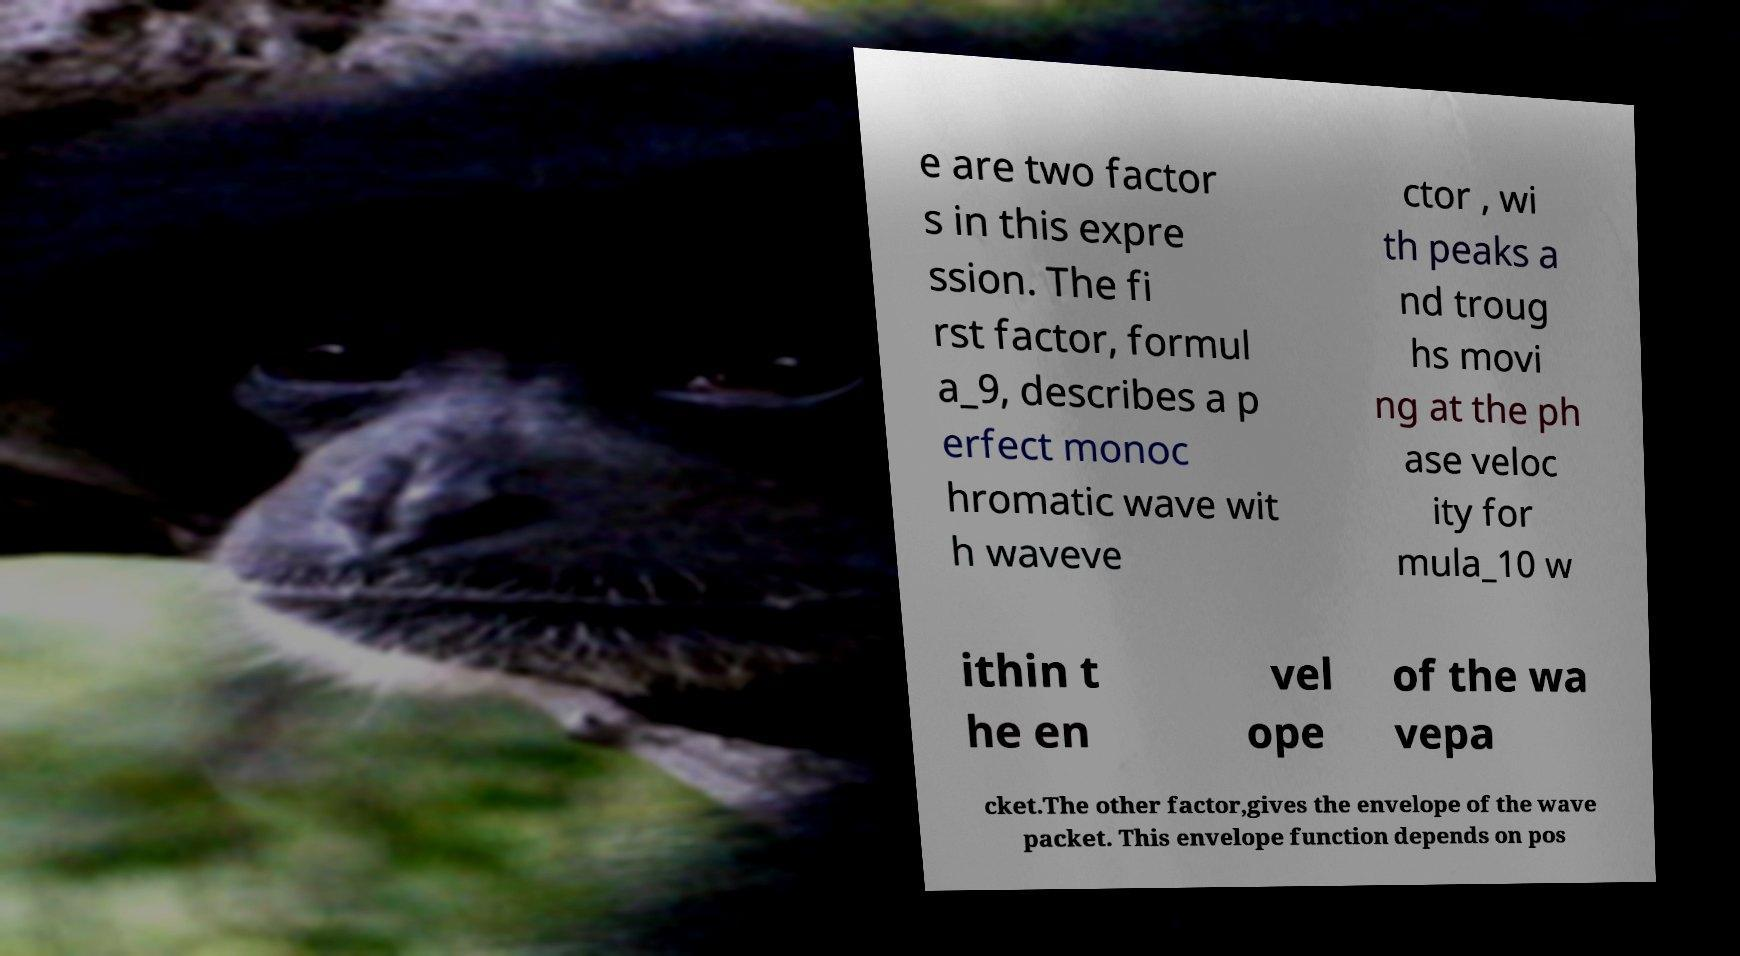I need the written content from this picture converted into text. Can you do that? e are two factor s in this expre ssion. The fi rst factor, formul a_9, describes a p erfect monoc hromatic wave wit h waveve ctor , wi th peaks a nd troug hs movi ng at the ph ase veloc ity for mula_10 w ithin t he en vel ope of the wa vepa cket.The other factor,gives the envelope of the wave packet. This envelope function depends on pos 